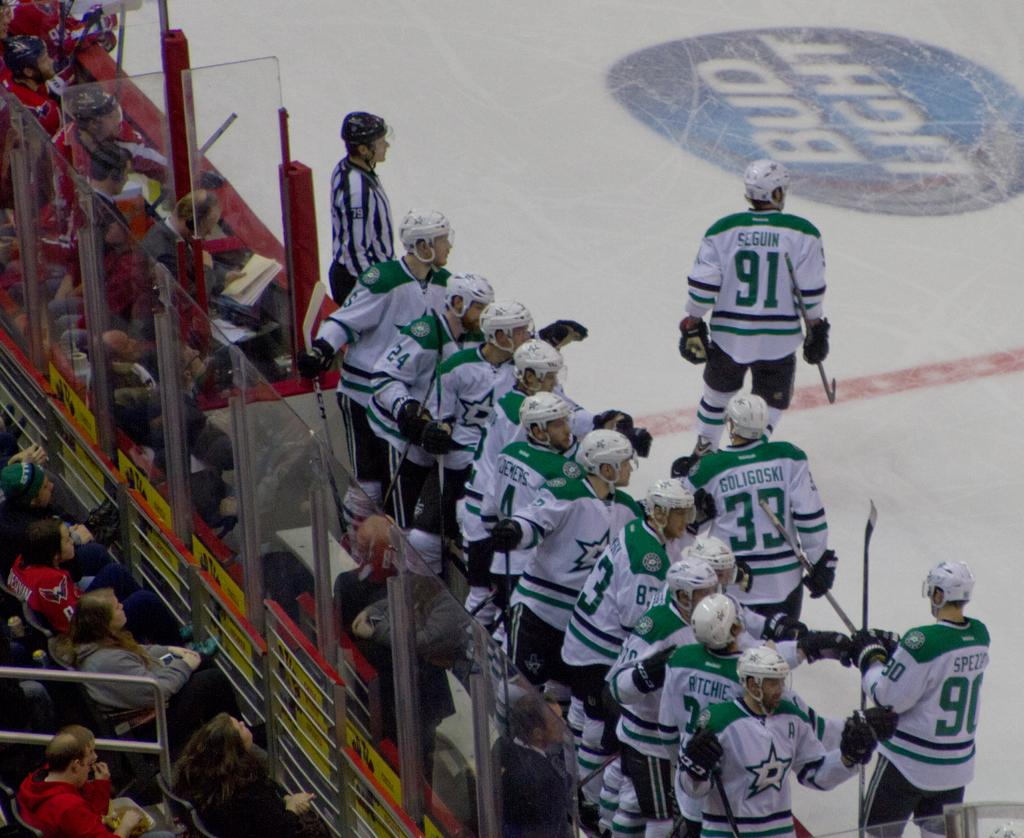Provide a one-sentence caption for the provided image. Ice hockey game featuring the Dallas Stars and player Tyler Seguin. 